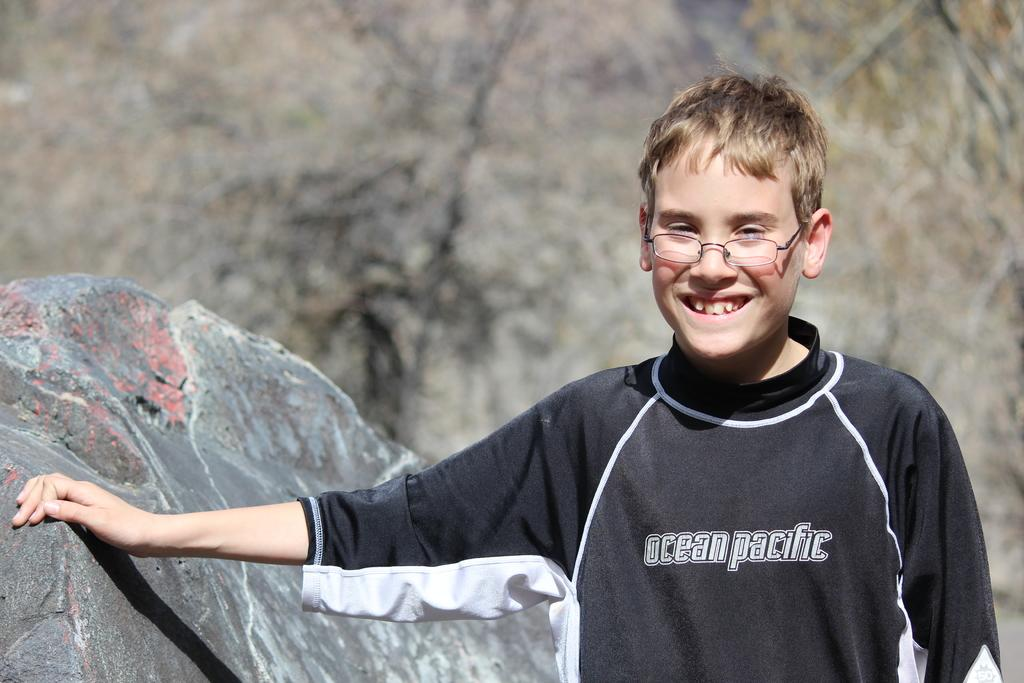What is the main subject of the image? The main subject of the image is a boy. What is the boy doing in the image? The boy is standing and smiling in the image. What can be seen on the boy's face? The boy is wearing spectacles in the image. What is located beside the boy? There is a rock beside the boy. How would you describe the background of the image? The background of the image is blurry. Can you tell me how many members are in the band that is performing in the image? There is no band performing in the image; it features a boy standing beside a rock. What type of bubble is floating near the boy in the image? There is no bubble present in the image. 